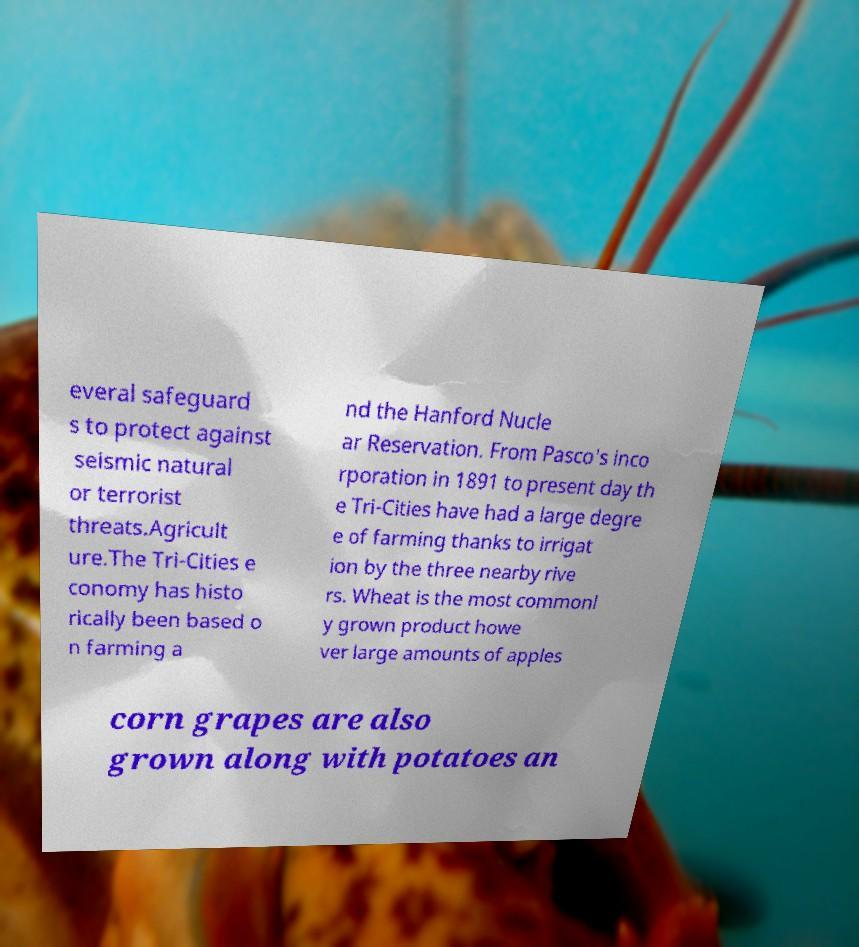I need the written content from this picture converted into text. Can you do that? everal safeguard s to protect against seismic natural or terrorist threats.Agricult ure.The Tri-Cities e conomy has histo rically been based o n farming a nd the Hanford Nucle ar Reservation. From Pasco's inco rporation in 1891 to present day th e Tri-Cities have had a large degre e of farming thanks to irrigat ion by the three nearby rive rs. Wheat is the most commonl y grown product howe ver large amounts of apples corn grapes are also grown along with potatoes an 